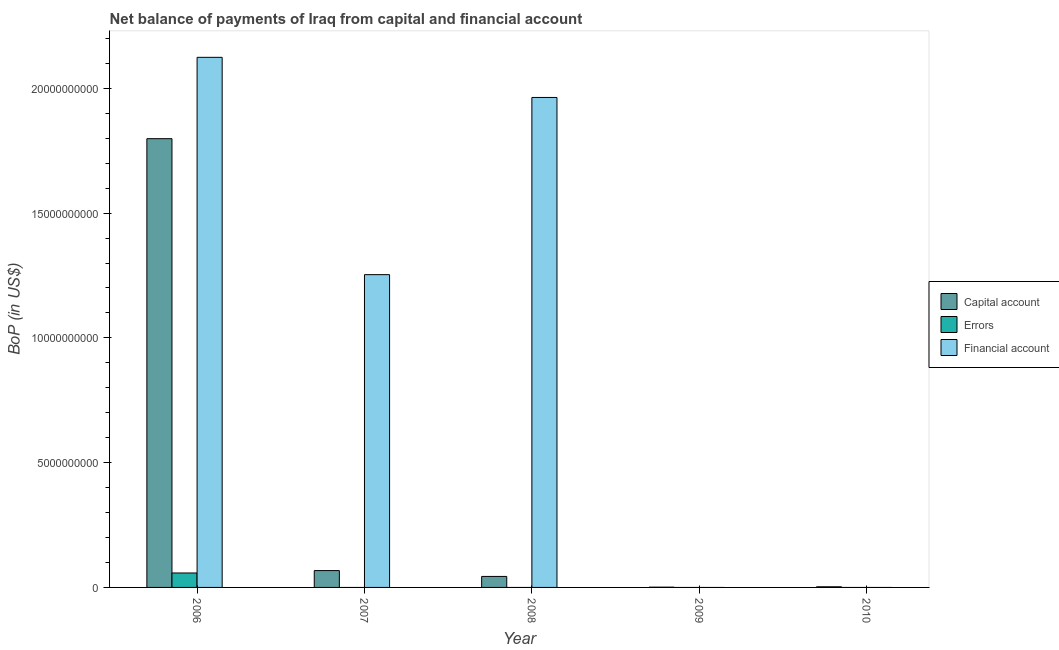Are the number of bars per tick equal to the number of legend labels?
Offer a very short reply. No. How many bars are there on the 4th tick from the right?
Keep it short and to the point. 2. In how many cases, is the number of bars for a given year not equal to the number of legend labels?
Your response must be concise. 4. What is the amount of errors in 2008?
Provide a succinct answer. 0. Across all years, what is the maximum amount of financial account?
Give a very brief answer. 2.12e+1. Across all years, what is the minimum amount of net capital account?
Provide a succinct answer. 1.02e+07. What is the total amount of financial account in the graph?
Keep it short and to the point. 5.34e+1. What is the difference between the amount of net capital account in 2006 and that in 2009?
Your answer should be very brief. 1.80e+1. What is the difference between the amount of errors in 2007 and the amount of financial account in 2008?
Provide a succinct answer. 0. What is the average amount of financial account per year?
Keep it short and to the point. 1.07e+1. In how many years, is the amount of net capital account greater than 10000000000 US$?
Offer a terse response. 1. What is the ratio of the amount of net capital account in 2006 to that in 2008?
Make the answer very short. 40.8. Is the difference between the amount of net capital account in 2007 and 2009 greater than the difference between the amount of errors in 2007 and 2009?
Ensure brevity in your answer.  No. What is the difference between the highest and the second highest amount of financial account?
Your response must be concise. 1.61e+09. What is the difference between the highest and the lowest amount of net capital account?
Your answer should be compact. 1.80e+1. How many bars are there?
Your response must be concise. 9. How many years are there in the graph?
Ensure brevity in your answer.  5. What is the difference between two consecutive major ticks on the Y-axis?
Offer a terse response. 5.00e+09. Are the values on the major ticks of Y-axis written in scientific E-notation?
Ensure brevity in your answer.  No. Does the graph contain grids?
Provide a short and direct response. No. Where does the legend appear in the graph?
Make the answer very short. Center right. What is the title of the graph?
Your response must be concise. Net balance of payments of Iraq from capital and financial account. Does "Social Protection and Labor" appear as one of the legend labels in the graph?
Your response must be concise. No. What is the label or title of the X-axis?
Your answer should be compact. Year. What is the label or title of the Y-axis?
Offer a very short reply. BoP (in US$). What is the BoP (in US$) of Capital account in 2006?
Offer a very short reply. 1.80e+1. What is the BoP (in US$) of Errors in 2006?
Offer a very short reply. 5.79e+08. What is the BoP (in US$) in Financial account in 2006?
Offer a terse response. 2.12e+1. What is the BoP (in US$) in Capital account in 2007?
Keep it short and to the point. 6.75e+08. What is the BoP (in US$) in Financial account in 2007?
Offer a terse response. 1.25e+1. What is the BoP (in US$) in Capital account in 2008?
Your response must be concise. 4.41e+08. What is the BoP (in US$) in Errors in 2008?
Your response must be concise. 0. What is the BoP (in US$) of Financial account in 2008?
Provide a short and direct response. 1.96e+1. What is the BoP (in US$) of Capital account in 2009?
Provide a succinct answer. 1.02e+07. What is the BoP (in US$) of Financial account in 2009?
Ensure brevity in your answer.  0. What is the BoP (in US$) of Capital account in 2010?
Provide a succinct answer. 2.53e+07. What is the BoP (in US$) of Errors in 2010?
Provide a succinct answer. 0. What is the BoP (in US$) in Financial account in 2010?
Offer a terse response. 0. Across all years, what is the maximum BoP (in US$) in Capital account?
Offer a terse response. 1.80e+1. Across all years, what is the maximum BoP (in US$) in Errors?
Provide a short and direct response. 5.79e+08. Across all years, what is the maximum BoP (in US$) in Financial account?
Ensure brevity in your answer.  2.12e+1. Across all years, what is the minimum BoP (in US$) of Capital account?
Your response must be concise. 1.02e+07. Across all years, what is the minimum BoP (in US$) of Errors?
Your response must be concise. 0. What is the total BoP (in US$) of Capital account in the graph?
Offer a very short reply. 1.91e+1. What is the total BoP (in US$) in Errors in the graph?
Offer a very short reply. 5.79e+08. What is the total BoP (in US$) in Financial account in the graph?
Provide a succinct answer. 5.34e+1. What is the difference between the BoP (in US$) in Capital account in 2006 and that in 2007?
Ensure brevity in your answer.  1.73e+1. What is the difference between the BoP (in US$) of Financial account in 2006 and that in 2007?
Offer a terse response. 8.71e+09. What is the difference between the BoP (in US$) in Capital account in 2006 and that in 2008?
Your answer should be very brief. 1.75e+1. What is the difference between the BoP (in US$) of Financial account in 2006 and that in 2008?
Ensure brevity in your answer.  1.61e+09. What is the difference between the BoP (in US$) in Capital account in 2006 and that in 2009?
Your response must be concise. 1.80e+1. What is the difference between the BoP (in US$) in Capital account in 2006 and that in 2010?
Provide a succinct answer. 1.80e+1. What is the difference between the BoP (in US$) in Capital account in 2007 and that in 2008?
Keep it short and to the point. 2.34e+08. What is the difference between the BoP (in US$) in Financial account in 2007 and that in 2008?
Your answer should be compact. -7.10e+09. What is the difference between the BoP (in US$) of Capital account in 2007 and that in 2009?
Your response must be concise. 6.65e+08. What is the difference between the BoP (in US$) of Capital account in 2007 and that in 2010?
Ensure brevity in your answer.  6.50e+08. What is the difference between the BoP (in US$) in Capital account in 2008 and that in 2009?
Offer a very short reply. 4.31e+08. What is the difference between the BoP (in US$) of Capital account in 2008 and that in 2010?
Offer a very short reply. 4.16e+08. What is the difference between the BoP (in US$) in Capital account in 2009 and that in 2010?
Offer a terse response. -1.51e+07. What is the difference between the BoP (in US$) of Capital account in 2006 and the BoP (in US$) of Financial account in 2007?
Your answer should be very brief. 5.45e+09. What is the difference between the BoP (in US$) of Errors in 2006 and the BoP (in US$) of Financial account in 2007?
Keep it short and to the point. -1.20e+1. What is the difference between the BoP (in US$) in Capital account in 2006 and the BoP (in US$) in Financial account in 2008?
Make the answer very short. -1.65e+09. What is the difference between the BoP (in US$) in Errors in 2006 and the BoP (in US$) in Financial account in 2008?
Make the answer very short. -1.91e+1. What is the difference between the BoP (in US$) of Capital account in 2007 and the BoP (in US$) of Financial account in 2008?
Give a very brief answer. -1.90e+1. What is the average BoP (in US$) in Capital account per year?
Your answer should be very brief. 3.83e+09. What is the average BoP (in US$) in Errors per year?
Your answer should be compact. 1.16e+08. What is the average BoP (in US$) of Financial account per year?
Give a very brief answer. 1.07e+1. In the year 2006, what is the difference between the BoP (in US$) of Capital account and BoP (in US$) of Errors?
Offer a terse response. 1.74e+1. In the year 2006, what is the difference between the BoP (in US$) of Capital account and BoP (in US$) of Financial account?
Give a very brief answer. -3.26e+09. In the year 2006, what is the difference between the BoP (in US$) in Errors and BoP (in US$) in Financial account?
Your answer should be very brief. -2.07e+1. In the year 2007, what is the difference between the BoP (in US$) of Capital account and BoP (in US$) of Financial account?
Offer a terse response. -1.19e+1. In the year 2008, what is the difference between the BoP (in US$) in Capital account and BoP (in US$) in Financial account?
Provide a succinct answer. -1.92e+1. What is the ratio of the BoP (in US$) of Capital account in 2006 to that in 2007?
Ensure brevity in your answer.  26.64. What is the ratio of the BoP (in US$) of Financial account in 2006 to that in 2007?
Provide a succinct answer. 1.69. What is the ratio of the BoP (in US$) of Capital account in 2006 to that in 2008?
Your answer should be very brief. 40.8. What is the ratio of the BoP (in US$) of Financial account in 2006 to that in 2008?
Ensure brevity in your answer.  1.08. What is the ratio of the BoP (in US$) in Capital account in 2006 to that in 2009?
Ensure brevity in your answer.  1763.14. What is the ratio of the BoP (in US$) in Capital account in 2006 to that in 2010?
Offer a terse response. 710.83. What is the ratio of the BoP (in US$) in Capital account in 2007 to that in 2008?
Make the answer very short. 1.53. What is the ratio of the BoP (in US$) in Financial account in 2007 to that in 2008?
Your response must be concise. 0.64. What is the ratio of the BoP (in US$) of Capital account in 2007 to that in 2009?
Ensure brevity in your answer.  66.19. What is the ratio of the BoP (in US$) in Capital account in 2007 to that in 2010?
Provide a short and direct response. 26.68. What is the ratio of the BoP (in US$) in Capital account in 2008 to that in 2009?
Your response must be concise. 43.22. What is the ratio of the BoP (in US$) of Capital account in 2008 to that in 2010?
Ensure brevity in your answer.  17.42. What is the ratio of the BoP (in US$) in Capital account in 2009 to that in 2010?
Your answer should be compact. 0.4. What is the difference between the highest and the second highest BoP (in US$) of Capital account?
Your response must be concise. 1.73e+1. What is the difference between the highest and the second highest BoP (in US$) of Financial account?
Ensure brevity in your answer.  1.61e+09. What is the difference between the highest and the lowest BoP (in US$) in Capital account?
Your response must be concise. 1.80e+1. What is the difference between the highest and the lowest BoP (in US$) in Errors?
Your answer should be compact. 5.79e+08. What is the difference between the highest and the lowest BoP (in US$) of Financial account?
Your answer should be very brief. 2.12e+1. 